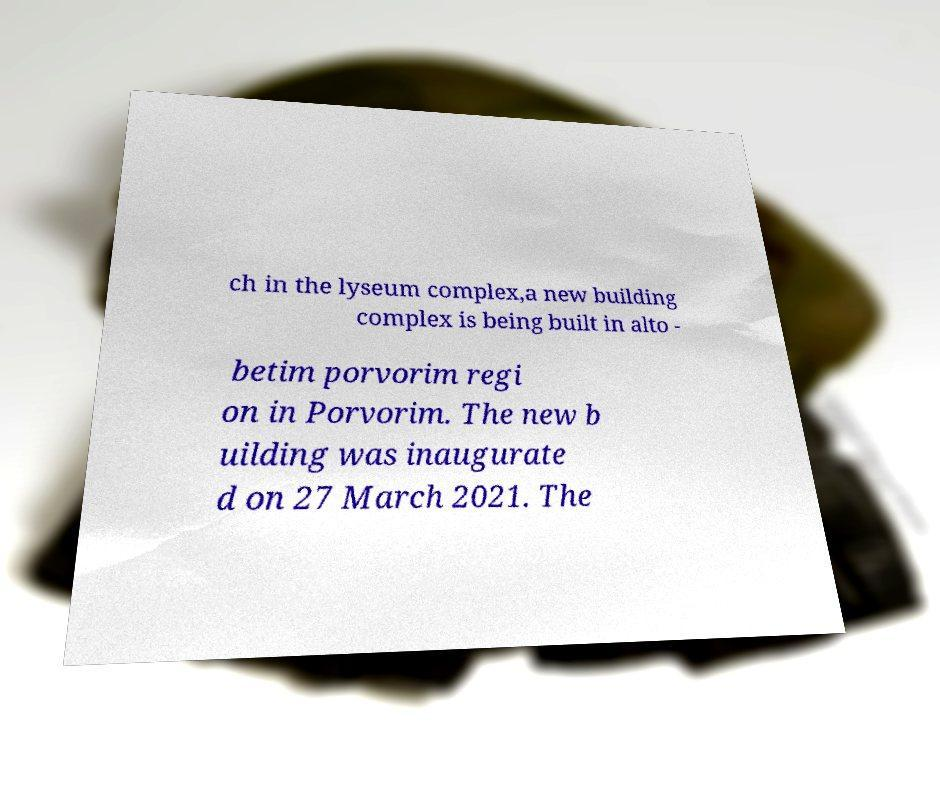Please identify and transcribe the text found in this image. ch in the lyseum complex,a new building complex is being built in alto - betim porvorim regi on in Porvorim. The new b uilding was inaugurate d on 27 March 2021. The 